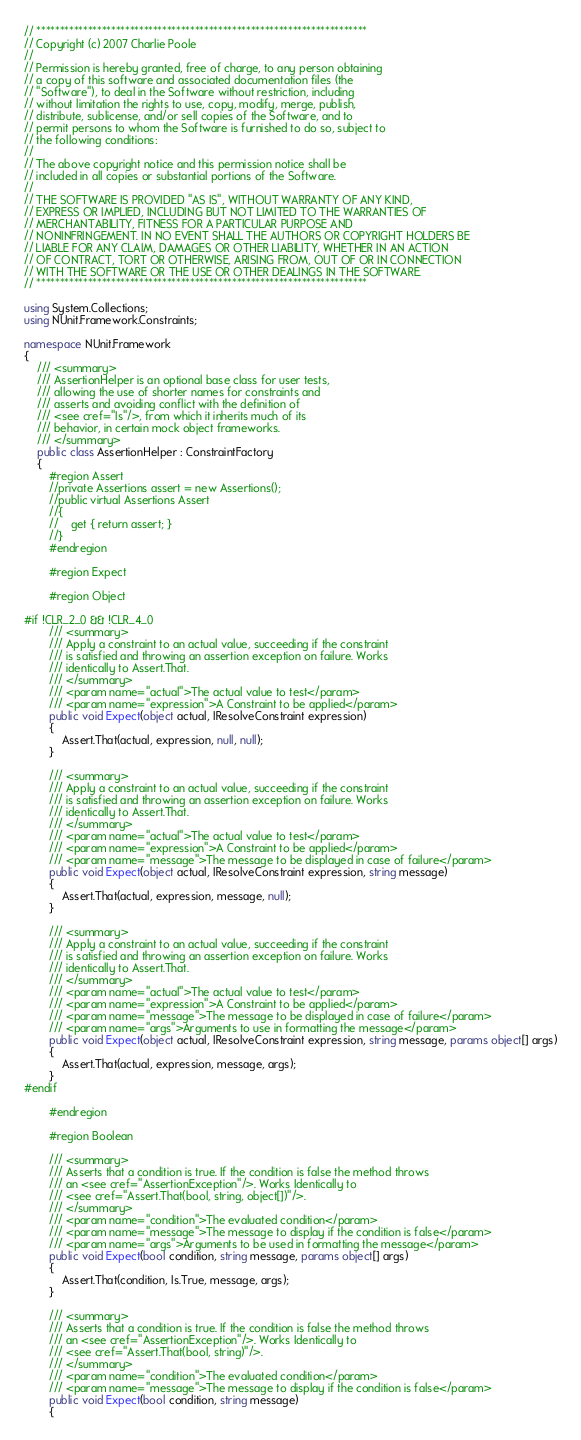<code> <loc_0><loc_0><loc_500><loc_500><_C#_>// ***********************************************************************
// Copyright (c) 2007 Charlie Poole
//
// Permission is hereby granted, free of charge, to any person obtaining
// a copy of this software and associated documentation files (the
// "Software"), to deal in the Software without restriction, including
// without limitation the rights to use, copy, modify, merge, publish,
// distribute, sublicense, and/or sell copies of the Software, and to
// permit persons to whom the Software is furnished to do so, subject to
// the following conditions:
//
// The above copyright notice and this permission notice shall be
// included in all copies or substantial portions of the Software.
//
// THE SOFTWARE IS PROVIDED "AS IS", WITHOUT WARRANTY OF ANY KIND,
// EXPRESS OR IMPLIED, INCLUDING BUT NOT LIMITED TO THE WARRANTIES OF
// MERCHANTABILITY, FITNESS FOR A PARTICULAR PURPOSE AND
// NONINFRINGEMENT. IN NO EVENT SHALL THE AUTHORS OR COPYRIGHT HOLDERS BE
// LIABLE FOR ANY CLAIM, DAMAGES OR OTHER LIABILITY, WHETHER IN AN ACTION
// OF CONTRACT, TORT OR OTHERWISE, ARISING FROM, OUT OF OR IN CONNECTION
// WITH THE SOFTWARE OR THE USE OR OTHER DEALINGS IN THE SOFTWARE.
// ***********************************************************************

using System.Collections;
using NUnit.Framework.Constraints;

namespace NUnit.Framework
{
	/// <summary>
	/// AssertionHelper is an optional base class for user tests,
	/// allowing the use of shorter names for constraints and
	/// asserts and avoiding conflict with the definition of
	/// <see cref="Is"/>, from which it inherits much of its
	/// behavior, in certain mock object frameworks.
	/// </summary>
	public class AssertionHelper : ConstraintFactory
    {
        #region Assert
        //private Assertions assert = new Assertions();
        //public virtual Assertions Assert
        //{
        //    get { return assert; }
        //}
        #endregion

        #region Expect

        #region Object

#if !CLR_2_0 && !CLR_4_0
        /// <summary>
        /// Apply a constraint to an actual value, succeeding if the constraint
        /// is satisfied and throwing an assertion exception on failure. Works
        /// identically to Assert.That.
        /// </summary>
        /// <param name="actual">The actual value to test</param>
        /// <param name="expression">A Constraint to be applied</param>
        public void Expect(object actual, IResolveConstraint expression)
        {
            Assert.That(actual, expression, null, null);
        }

        /// <summary>
        /// Apply a constraint to an actual value, succeeding if the constraint
        /// is satisfied and throwing an assertion exception on failure. Works
        /// identically to Assert.That.
        /// </summary>
        /// <param name="actual">The actual value to test</param>
        /// <param name="expression">A Constraint to be applied</param>
        /// <param name="message">The message to be displayed in case of failure</param>
        public void Expect(object actual, IResolveConstraint expression, string message)
        {
            Assert.That(actual, expression, message, null);
        }

        /// <summary>
        /// Apply a constraint to an actual value, succeeding if the constraint
        /// is satisfied and throwing an assertion exception on failure. Works
        /// identically to Assert.That.
        /// </summary>
        /// <param name="actual">The actual value to test</param>
        /// <param name="expression">A Constraint to be applied</param>
        /// <param name="message">The message to be displayed in case of failure</param>
        /// <param name="args">Arguments to use in formatting the message</param>
        public void Expect(object actual, IResolveConstraint expression, string message, params object[] args)
        {
            Assert.That(actual, expression, message, args);
        }
#endif

        #endregion

        #region Boolean

        /// <summary>
        /// Asserts that a condition is true. If the condition is false the method throws
        /// an <see cref="AssertionException"/>. Works Identically to
        /// <see cref="Assert.That(bool, string, object[])"/>.
        /// </summary>
        /// <param name="condition">The evaluated condition</param>
        /// <param name="message">The message to display if the condition is false</param>
        /// <param name="args">Arguments to be used in formatting the message</param>
        public void Expect(bool condition, string message, params object[] args)
        {
            Assert.That(condition, Is.True, message, args);
        }

        /// <summary>
        /// Asserts that a condition is true. If the condition is false the method throws
        /// an <see cref="AssertionException"/>. Works Identically to
        /// <see cref="Assert.That(bool, string)"/>.
        /// </summary>
        /// <param name="condition">The evaluated condition</param>
        /// <param name="message">The message to display if the condition is false</param>
        public void Expect(bool condition, string message)
        {</code> 